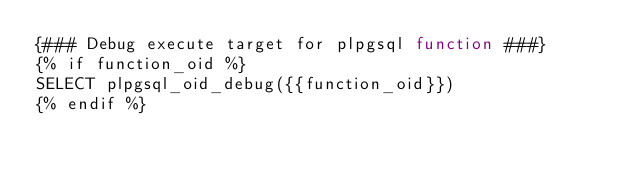Convert code to text. <code><loc_0><loc_0><loc_500><loc_500><_SQL_>{### Debug execute target for plpgsql function ###}
{% if function_oid %}
SELECT plpgsql_oid_debug({{function_oid}})
{% endif %}</code> 